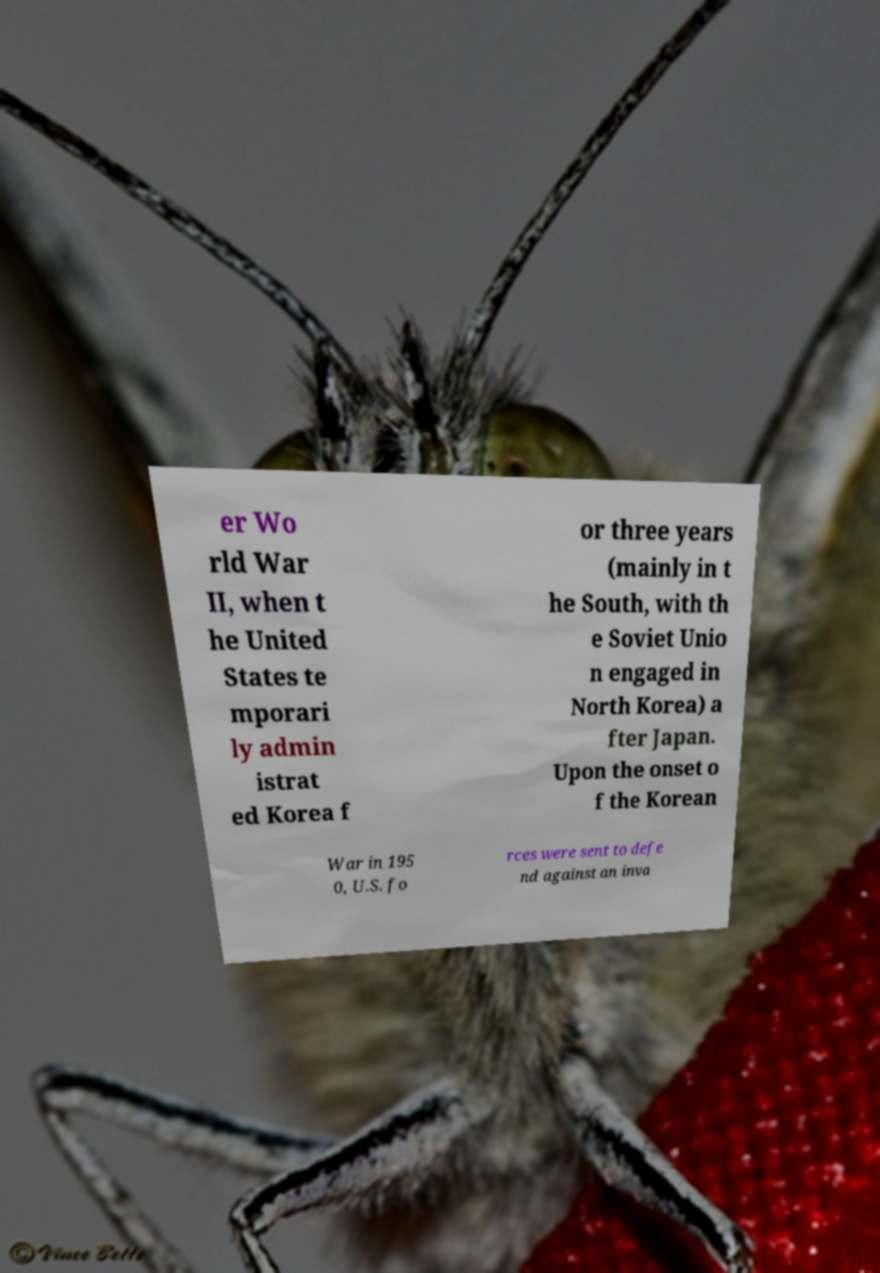Can you read and provide the text displayed in the image?This photo seems to have some interesting text. Can you extract and type it out for me? er Wo rld War II, when t he United States te mporari ly admin istrat ed Korea f or three years (mainly in t he South, with th e Soviet Unio n engaged in North Korea) a fter Japan. Upon the onset o f the Korean War in 195 0, U.S. fo rces were sent to defe nd against an inva 